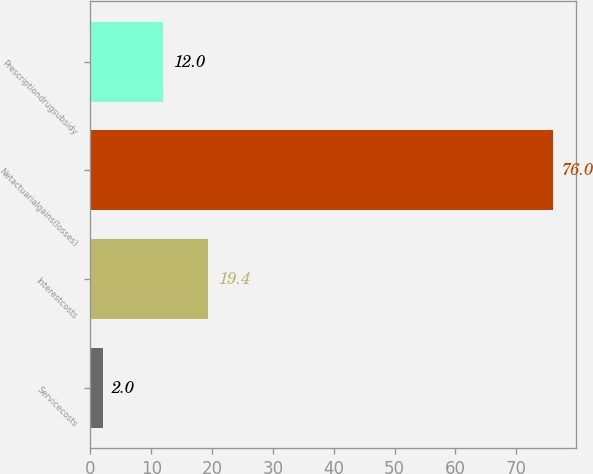Convert chart. <chart><loc_0><loc_0><loc_500><loc_500><bar_chart><fcel>Servicecosts<fcel>Interestcosts<fcel>Netactuarialgains(losses)<fcel>Prescriptiondrugsubsidy<nl><fcel>2<fcel>19.4<fcel>76<fcel>12<nl></chart> 